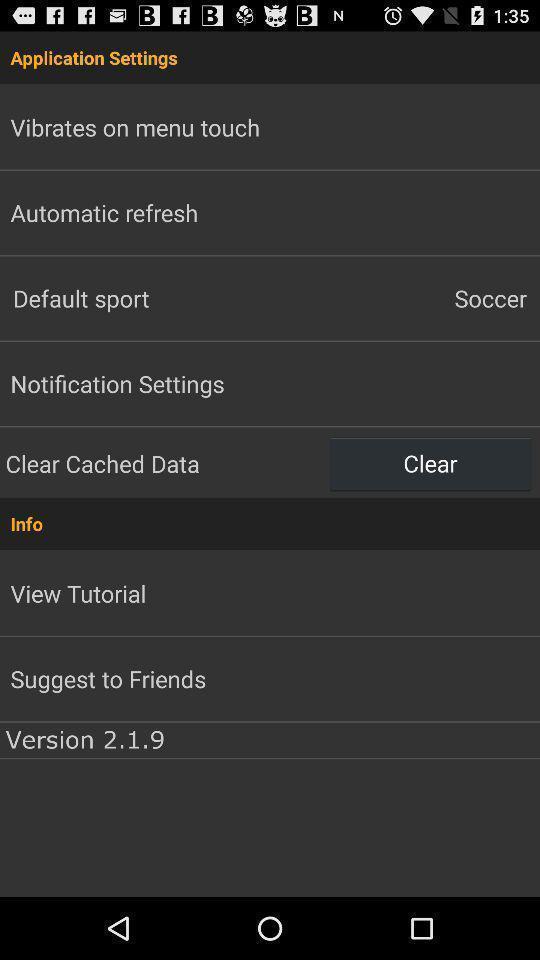Explain the elements present in this screenshot. Screen showing application settings page. 